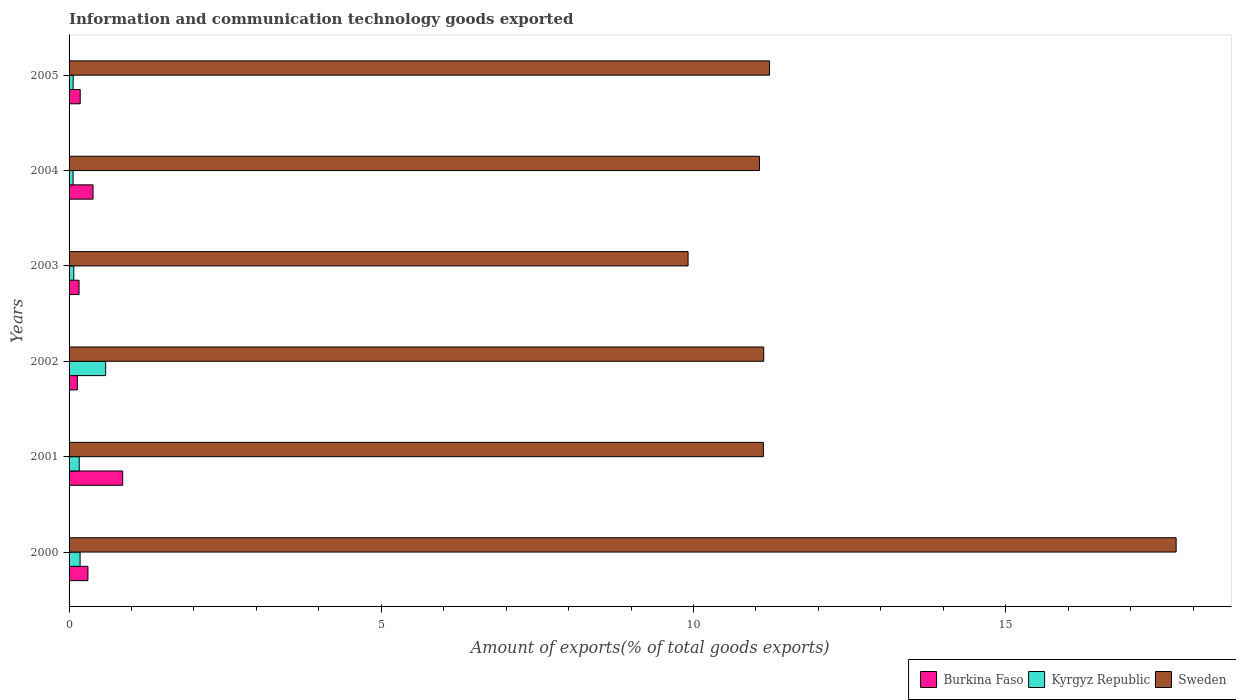How many different coloured bars are there?
Offer a very short reply. 3. How many groups of bars are there?
Offer a very short reply. 6. Are the number of bars on each tick of the Y-axis equal?
Make the answer very short. Yes. How many bars are there on the 4th tick from the top?
Provide a short and direct response. 3. How many bars are there on the 5th tick from the bottom?
Your response must be concise. 3. What is the label of the 5th group of bars from the top?
Provide a short and direct response. 2001. What is the amount of goods exported in Sweden in 2001?
Provide a short and direct response. 11.12. Across all years, what is the maximum amount of goods exported in Burkina Faso?
Your response must be concise. 0.86. Across all years, what is the minimum amount of goods exported in Sweden?
Your response must be concise. 9.91. In which year was the amount of goods exported in Sweden maximum?
Keep it short and to the point. 2000. In which year was the amount of goods exported in Burkina Faso minimum?
Your response must be concise. 2002. What is the total amount of goods exported in Burkina Faso in the graph?
Your answer should be compact. 2.02. What is the difference between the amount of goods exported in Burkina Faso in 2004 and that in 2005?
Offer a terse response. 0.21. What is the difference between the amount of goods exported in Burkina Faso in 2004 and the amount of goods exported in Kyrgyz Republic in 2003?
Provide a succinct answer. 0.31. What is the average amount of goods exported in Sweden per year?
Make the answer very short. 12.03. In the year 2005, what is the difference between the amount of goods exported in Kyrgyz Republic and amount of goods exported in Sweden?
Your answer should be very brief. -11.15. In how many years, is the amount of goods exported in Sweden greater than 1 %?
Ensure brevity in your answer.  6. What is the ratio of the amount of goods exported in Burkina Faso in 2000 to that in 2001?
Your answer should be very brief. 0.35. Is the amount of goods exported in Burkina Faso in 2003 less than that in 2004?
Offer a terse response. Yes. What is the difference between the highest and the second highest amount of goods exported in Burkina Faso?
Your answer should be compact. 0.48. What is the difference between the highest and the lowest amount of goods exported in Kyrgyz Republic?
Your answer should be compact. 0.52. In how many years, is the amount of goods exported in Sweden greater than the average amount of goods exported in Sweden taken over all years?
Offer a very short reply. 1. What does the 1st bar from the top in 2001 represents?
Your answer should be very brief. Sweden. Is it the case that in every year, the sum of the amount of goods exported in Kyrgyz Republic and amount of goods exported in Burkina Faso is greater than the amount of goods exported in Sweden?
Provide a succinct answer. No. Are all the bars in the graph horizontal?
Ensure brevity in your answer.  Yes. How many years are there in the graph?
Offer a terse response. 6. Are the values on the major ticks of X-axis written in scientific E-notation?
Offer a terse response. No. Does the graph contain any zero values?
Your answer should be compact. No. Does the graph contain grids?
Make the answer very short. No. Where does the legend appear in the graph?
Give a very brief answer. Bottom right. How many legend labels are there?
Your answer should be compact. 3. How are the legend labels stacked?
Give a very brief answer. Horizontal. What is the title of the graph?
Provide a short and direct response. Information and communication technology goods exported. What is the label or title of the X-axis?
Provide a short and direct response. Amount of exports(% of total goods exports). What is the Amount of exports(% of total goods exports) in Burkina Faso in 2000?
Provide a succinct answer. 0.3. What is the Amount of exports(% of total goods exports) of Kyrgyz Republic in 2000?
Provide a short and direct response. 0.18. What is the Amount of exports(% of total goods exports) of Sweden in 2000?
Offer a terse response. 17.73. What is the Amount of exports(% of total goods exports) in Burkina Faso in 2001?
Ensure brevity in your answer.  0.86. What is the Amount of exports(% of total goods exports) in Kyrgyz Republic in 2001?
Your response must be concise. 0.16. What is the Amount of exports(% of total goods exports) of Sweden in 2001?
Offer a terse response. 11.12. What is the Amount of exports(% of total goods exports) of Burkina Faso in 2002?
Make the answer very short. 0.13. What is the Amount of exports(% of total goods exports) of Kyrgyz Republic in 2002?
Make the answer very short. 0.59. What is the Amount of exports(% of total goods exports) of Sweden in 2002?
Ensure brevity in your answer.  11.13. What is the Amount of exports(% of total goods exports) of Burkina Faso in 2003?
Make the answer very short. 0.16. What is the Amount of exports(% of total goods exports) in Kyrgyz Republic in 2003?
Give a very brief answer. 0.08. What is the Amount of exports(% of total goods exports) of Sweden in 2003?
Your answer should be compact. 9.91. What is the Amount of exports(% of total goods exports) in Burkina Faso in 2004?
Offer a very short reply. 0.38. What is the Amount of exports(% of total goods exports) in Kyrgyz Republic in 2004?
Your answer should be compact. 0.06. What is the Amount of exports(% of total goods exports) in Sweden in 2004?
Offer a terse response. 11.06. What is the Amount of exports(% of total goods exports) of Burkina Faso in 2005?
Provide a short and direct response. 0.18. What is the Amount of exports(% of total goods exports) of Kyrgyz Republic in 2005?
Offer a very short reply. 0.07. What is the Amount of exports(% of total goods exports) in Sweden in 2005?
Provide a succinct answer. 11.22. Across all years, what is the maximum Amount of exports(% of total goods exports) of Burkina Faso?
Give a very brief answer. 0.86. Across all years, what is the maximum Amount of exports(% of total goods exports) of Kyrgyz Republic?
Offer a very short reply. 0.59. Across all years, what is the maximum Amount of exports(% of total goods exports) in Sweden?
Offer a terse response. 17.73. Across all years, what is the minimum Amount of exports(% of total goods exports) of Burkina Faso?
Provide a short and direct response. 0.13. Across all years, what is the minimum Amount of exports(% of total goods exports) in Kyrgyz Republic?
Your answer should be compact. 0.06. Across all years, what is the minimum Amount of exports(% of total goods exports) of Sweden?
Your answer should be very brief. 9.91. What is the total Amount of exports(% of total goods exports) in Burkina Faso in the graph?
Keep it short and to the point. 2.02. What is the total Amount of exports(% of total goods exports) in Kyrgyz Republic in the graph?
Your response must be concise. 1.13. What is the total Amount of exports(% of total goods exports) in Sweden in the graph?
Keep it short and to the point. 72.16. What is the difference between the Amount of exports(% of total goods exports) of Burkina Faso in 2000 and that in 2001?
Provide a short and direct response. -0.56. What is the difference between the Amount of exports(% of total goods exports) of Kyrgyz Republic in 2000 and that in 2001?
Offer a terse response. 0.01. What is the difference between the Amount of exports(% of total goods exports) of Sweden in 2000 and that in 2001?
Make the answer very short. 6.61. What is the difference between the Amount of exports(% of total goods exports) in Burkina Faso in 2000 and that in 2002?
Give a very brief answer. 0.17. What is the difference between the Amount of exports(% of total goods exports) in Kyrgyz Republic in 2000 and that in 2002?
Offer a terse response. -0.41. What is the difference between the Amount of exports(% of total goods exports) of Sweden in 2000 and that in 2002?
Your answer should be very brief. 6.6. What is the difference between the Amount of exports(% of total goods exports) in Burkina Faso in 2000 and that in 2003?
Your answer should be compact. 0.14. What is the difference between the Amount of exports(% of total goods exports) in Kyrgyz Republic in 2000 and that in 2003?
Your answer should be very brief. 0.1. What is the difference between the Amount of exports(% of total goods exports) of Sweden in 2000 and that in 2003?
Provide a succinct answer. 7.82. What is the difference between the Amount of exports(% of total goods exports) of Burkina Faso in 2000 and that in 2004?
Give a very brief answer. -0.08. What is the difference between the Amount of exports(% of total goods exports) in Kyrgyz Republic in 2000 and that in 2004?
Ensure brevity in your answer.  0.11. What is the difference between the Amount of exports(% of total goods exports) in Sweden in 2000 and that in 2004?
Your response must be concise. 6.67. What is the difference between the Amount of exports(% of total goods exports) of Burkina Faso in 2000 and that in 2005?
Keep it short and to the point. 0.12. What is the difference between the Amount of exports(% of total goods exports) of Kyrgyz Republic in 2000 and that in 2005?
Your answer should be very brief. 0.11. What is the difference between the Amount of exports(% of total goods exports) of Sweden in 2000 and that in 2005?
Offer a very short reply. 6.51. What is the difference between the Amount of exports(% of total goods exports) in Burkina Faso in 2001 and that in 2002?
Ensure brevity in your answer.  0.73. What is the difference between the Amount of exports(% of total goods exports) of Kyrgyz Republic in 2001 and that in 2002?
Ensure brevity in your answer.  -0.42. What is the difference between the Amount of exports(% of total goods exports) in Sweden in 2001 and that in 2002?
Offer a terse response. -0.01. What is the difference between the Amount of exports(% of total goods exports) of Burkina Faso in 2001 and that in 2003?
Ensure brevity in your answer.  0.7. What is the difference between the Amount of exports(% of total goods exports) in Kyrgyz Republic in 2001 and that in 2003?
Provide a short and direct response. 0.09. What is the difference between the Amount of exports(% of total goods exports) in Sweden in 2001 and that in 2003?
Give a very brief answer. 1.21. What is the difference between the Amount of exports(% of total goods exports) in Burkina Faso in 2001 and that in 2004?
Your answer should be compact. 0.47. What is the difference between the Amount of exports(% of total goods exports) in Kyrgyz Republic in 2001 and that in 2004?
Provide a succinct answer. 0.1. What is the difference between the Amount of exports(% of total goods exports) in Sweden in 2001 and that in 2004?
Provide a short and direct response. 0.06. What is the difference between the Amount of exports(% of total goods exports) of Burkina Faso in 2001 and that in 2005?
Offer a terse response. 0.68. What is the difference between the Amount of exports(% of total goods exports) in Kyrgyz Republic in 2001 and that in 2005?
Your answer should be compact. 0.1. What is the difference between the Amount of exports(% of total goods exports) of Sweden in 2001 and that in 2005?
Provide a succinct answer. -0.1. What is the difference between the Amount of exports(% of total goods exports) of Burkina Faso in 2002 and that in 2003?
Offer a terse response. -0.03. What is the difference between the Amount of exports(% of total goods exports) in Kyrgyz Republic in 2002 and that in 2003?
Your response must be concise. 0.51. What is the difference between the Amount of exports(% of total goods exports) in Sweden in 2002 and that in 2003?
Your answer should be very brief. 1.21. What is the difference between the Amount of exports(% of total goods exports) of Burkina Faso in 2002 and that in 2004?
Your answer should be very brief. -0.25. What is the difference between the Amount of exports(% of total goods exports) in Kyrgyz Republic in 2002 and that in 2004?
Your answer should be compact. 0.52. What is the difference between the Amount of exports(% of total goods exports) in Sweden in 2002 and that in 2004?
Keep it short and to the point. 0.07. What is the difference between the Amount of exports(% of total goods exports) of Burkina Faso in 2002 and that in 2005?
Your answer should be very brief. -0.05. What is the difference between the Amount of exports(% of total goods exports) of Kyrgyz Republic in 2002 and that in 2005?
Your response must be concise. 0.52. What is the difference between the Amount of exports(% of total goods exports) in Sweden in 2002 and that in 2005?
Your response must be concise. -0.09. What is the difference between the Amount of exports(% of total goods exports) of Burkina Faso in 2003 and that in 2004?
Make the answer very short. -0.22. What is the difference between the Amount of exports(% of total goods exports) of Kyrgyz Republic in 2003 and that in 2004?
Provide a short and direct response. 0.01. What is the difference between the Amount of exports(% of total goods exports) in Sweden in 2003 and that in 2004?
Give a very brief answer. -1.14. What is the difference between the Amount of exports(% of total goods exports) in Burkina Faso in 2003 and that in 2005?
Your answer should be compact. -0.02. What is the difference between the Amount of exports(% of total goods exports) in Kyrgyz Republic in 2003 and that in 2005?
Your answer should be very brief. 0.01. What is the difference between the Amount of exports(% of total goods exports) in Sweden in 2003 and that in 2005?
Offer a terse response. -1.3. What is the difference between the Amount of exports(% of total goods exports) in Burkina Faso in 2004 and that in 2005?
Your response must be concise. 0.21. What is the difference between the Amount of exports(% of total goods exports) in Kyrgyz Republic in 2004 and that in 2005?
Your answer should be compact. -0. What is the difference between the Amount of exports(% of total goods exports) of Sweden in 2004 and that in 2005?
Ensure brevity in your answer.  -0.16. What is the difference between the Amount of exports(% of total goods exports) of Burkina Faso in 2000 and the Amount of exports(% of total goods exports) of Kyrgyz Republic in 2001?
Keep it short and to the point. 0.14. What is the difference between the Amount of exports(% of total goods exports) of Burkina Faso in 2000 and the Amount of exports(% of total goods exports) of Sweden in 2001?
Provide a short and direct response. -10.82. What is the difference between the Amount of exports(% of total goods exports) of Kyrgyz Republic in 2000 and the Amount of exports(% of total goods exports) of Sweden in 2001?
Ensure brevity in your answer.  -10.94. What is the difference between the Amount of exports(% of total goods exports) of Burkina Faso in 2000 and the Amount of exports(% of total goods exports) of Kyrgyz Republic in 2002?
Provide a short and direct response. -0.28. What is the difference between the Amount of exports(% of total goods exports) of Burkina Faso in 2000 and the Amount of exports(% of total goods exports) of Sweden in 2002?
Keep it short and to the point. -10.82. What is the difference between the Amount of exports(% of total goods exports) in Kyrgyz Republic in 2000 and the Amount of exports(% of total goods exports) in Sweden in 2002?
Make the answer very short. -10.95. What is the difference between the Amount of exports(% of total goods exports) in Burkina Faso in 2000 and the Amount of exports(% of total goods exports) in Kyrgyz Republic in 2003?
Offer a terse response. 0.23. What is the difference between the Amount of exports(% of total goods exports) in Burkina Faso in 2000 and the Amount of exports(% of total goods exports) in Sweden in 2003?
Give a very brief answer. -9.61. What is the difference between the Amount of exports(% of total goods exports) of Kyrgyz Republic in 2000 and the Amount of exports(% of total goods exports) of Sweden in 2003?
Your response must be concise. -9.74. What is the difference between the Amount of exports(% of total goods exports) in Burkina Faso in 2000 and the Amount of exports(% of total goods exports) in Kyrgyz Republic in 2004?
Your answer should be compact. 0.24. What is the difference between the Amount of exports(% of total goods exports) of Burkina Faso in 2000 and the Amount of exports(% of total goods exports) of Sweden in 2004?
Provide a short and direct response. -10.75. What is the difference between the Amount of exports(% of total goods exports) of Kyrgyz Republic in 2000 and the Amount of exports(% of total goods exports) of Sweden in 2004?
Ensure brevity in your answer.  -10.88. What is the difference between the Amount of exports(% of total goods exports) of Burkina Faso in 2000 and the Amount of exports(% of total goods exports) of Kyrgyz Republic in 2005?
Provide a short and direct response. 0.24. What is the difference between the Amount of exports(% of total goods exports) of Burkina Faso in 2000 and the Amount of exports(% of total goods exports) of Sweden in 2005?
Offer a terse response. -10.92. What is the difference between the Amount of exports(% of total goods exports) of Kyrgyz Republic in 2000 and the Amount of exports(% of total goods exports) of Sweden in 2005?
Provide a succinct answer. -11.04. What is the difference between the Amount of exports(% of total goods exports) of Burkina Faso in 2001 and the Amount of exports(% of total goods exports) of Kyrgyz Republic in 2002?
Your answer should be very brief. 0.27. What is the difference between the Amount of exports(% of total goods exports) in Burkina Faso in 2001 and the Amount of exports(% of total goods exports) in Sweden in 2002?
Offer a very short reply. -10.27. What is the difference between the Amount of exports(% of total goods exports) of Kyrgyz Republic in 2001 and the Amount of exports(% of total goods exports) of Sweden in 2002?
Provide a succinct answer. -10.96. What is the difference between the Amount of exports(% of total goods exports) of Burkina Faso in 2001 and the Amount of exports(% of total goods exports) of Kyrgyz Republic in 2003?
Your response must be concise. 0.78. What is the difference between the Amount of exports(% of total goods exports) in Burkina Faso in 2001 and the Amount of exports(% of total goods exports) in Sweden in 2003?
Keep it short and to the point. -9.05. What is the difference between the Amount of exports(% of total goods exports) in Kyrgyz Republic in 2001 and the Amount of exports(% of total goods exports) in Sweden in 2003?
Keep it short and to the point. -9.75. What is the difference between the Amount of exports(% of total goods exports) of Burkina Faso in 2001 and the Amount of exports(% of total goods exports) of Kyrgyz Republic in 2004?
Provide a short and direct response. 0.8. What is the difference between the Amount of exports(% of total goods exports) in Burkina Faso in 2001 and the Amount of exports(% of total goods exports) in Sweden in 2004?
Provide a short and direct response. -10.2. What is the difference between the Amount of exports(% of total goods exports) in Kyrgyz Republic in 2001 and the Amount of exports(% of total goods exports) in Sweden in 2004?
Provide a succinct answer. -10.89. What is the difference between the Amount of exports(% of total goods exports) of Burkina Faso in 2001 and the Amount of exports(% of total goods exports) of Kyrgyz Republic in 2005?
Your answer should be compact. 0.79. What is the difference between the Amount of exports(% of total goods exports) in Burkina Faso in 2001 and the Amount of exports(% of total goods exports) in Sweden in 2005?
Offer a terse response. -10.36. What is the difference between the Amount of exports(% of total goods exports) of Kyrgyz Republic in 2001 and the Amount of exports(% of total goods exports) of Sweden in 2005?
Your response must be concise. -11.06. What is the difference between the Amount of exports(% of total goods exports) in Burkina Faso in 2002 and the Amount of exports(% of total goods exports) in Kyrgyz Republic in 2003?
Provide a succinct answer. 0.06. What is the difference between the Amount of exports(% of total goods exports) in Burkina Faso in 2002 and the Amount of exports(% of total goods exports) in Sweden in 2003?
Ensure brevity in your answer.  -9.78. What is the difference between the Amount of exports(% of total goods exports) in Kyrgyz Republic in 2002 and the Amount of exports(% of total goods exports) in Sweden in 2003?
Give a very brief answer. -9.33. What is the difference between the Amount of exports(% of total goods exports) in Burkina Faso in 2002 and the Amount of exports(% of total goods exports) in Kyrgyz Republic in 2004?
Make the answer very short. 0.07. What is the difference between the Amount of exports(% of total goods exports) in Burkina Faso in 2002 and the Amount of exports(% of total goods exports) in Sweden in 2004?
Provide a succinct answer. -10.92. What is the difference between the Amount of exports(% of total goods exports) of Kyrgyz Republic in 2002 and the Amount of exports(% of total goods exports) of Sweden in 2004?
Offer a terse response. -10.47. What is the difference between the Amount of exports(% of total goods exports) in Burkina Faso in 2002 and the Amount of exports(% of total goods exports) in Kyrgyz Republic in 2005?
Make the answer very short. 0.07. What is the difference between the Amount of exports(% of total goods exports) in Burkina Faso in 2002 and the Amount of exports(% of total goods exports) in Sweden in 2005?
Provide a short and direct response. -11.09. What is the difference between the Amount of exports(% of total goods exports) of Kyrgyz Republic in 2002 and the Amount of exports(% of total goods exports) of Sweden in 2005?
Provide a short and direct response. -10.63. What is the difference between the Amount of exports(% of total goods exports) in Burkina Faso in 2003 and the Amount of exports(% of total goods exports) in Kyrgyz Republic in 2004?
Provide a succinct answer. 0.1. What is the difference between the Amount of exports(% of total goods exports) of Burkina Faso in 2003 and the Amount of exports(% of total goods exports) of Sweden in 2004?
Your response must be concise. -10.9. What is the difference between the Amount of exports(% of total goods exports) of Kyrgyz Republic in 2003 and the Amount of exports(% of total goods exports) of Sweden in 2004?
Your response must be concise. -10.98. What is the difference between the Amount of exports(% of total goods exports) of Burkina Faso in 2003 and the Amount of exports(% of total goods exports) of Kyrgyz Republic in 2005?
Your answer should be compact. 0.09. What is the difference between the Amount of exports(% of total goods exports) of Burkina Faso in 2003 and the Amount of exports(% of total goods exports) of Sweden in 2005?
Keep it short and to the point. -11.06. What is the difference between the Amount of exports(% of total goods exports) of Kyrgyz Republic in 2003 and the Amount of exports(% of total goods exports) of Sweden in 2005?
Your answer should be compact. -11.14. What is the difference between the Amount of exports(% of total goods exports) of Burkina Faso in 2004 and the Amount of exports(% of total goods exports) of Kyrgyz Republic in 2005?
Make the answer very short. 0.32. What is the difference between the Amount of exports(% of total goods exports) of Burkina Faso in 2004 and the Amount of exports(% of total goods exports) of Sweden in 2005?
Give a very brief answer. -10.83. What is the difference between the Amount of exports(% of total goods exports) of Kyrgyz Republic in 2004 and the Amount of exports(% of total goods exports) of Sweden in 2005?
Provide a succinct answer. -11.15. What is the average Amount of exports(% of total goods exports) in Burkina Faso per year?
Your answer should be very brief. 0.34. What is the average Amount of exports(% of total goods exports) in Kyrgyz Republic per year?
Keep it short and to the point. 0.19. What is the average Amount of exports(% of total goods exports) of Sweden per year?
Your answer should be very brief. 12.03. In the year 2000, what is the difference between the Amount of exports(% of total goods exports) of Burkina Faso and Amount of exports(% of total goods exports) of Kyrgyz Republic?
Your answer should be compact. 0.13. In the year 2000, what is the difference between the Amount of exports(% of total goods exports) of Burkina Faso and Amount of exports(% of total goods exports) of Sweden?
Make the answer very short. -17.43. In the year 2000, what is the difference between the Amount of exports(% of total goods exports) of Kyrgyz Republic and Amount of exports(% of total goods exports) of Sweden?
Ensure brevity in your answer.  -17.55. In the year 2001, what is the difference between the Amount of exports(% of total goods exports) in Burkina Faso and Amount of exports(% of total goods exports) in Kyrgyz Republic?
Keep it short and to the point. 0.7. In the year 2001, what is the difference between the Amount of exports(% of total goods exports) in Burkina Faso and Amount of exports(% of total goods exports) in Sweden?
Keep it short and to the point. -10.26. In the year 2001, what is the difference between the Amount of exports(% of total goods exports) in Kyrgyz Republic and Amount of exports(% of total goods exports) in Sweden?
Your answer should be compact. -10.96. In the year 2002, what is the difference between the Amount of exports(% of total goods exports) of Burkina Faso and Amount of exports(% of total goods exports) of Kyrgyz Republic?
Your response must be concise. -0.45. In the year 2002, what is the difference between the Amount of exports(% of total goods exports) of Burkina Faso and Amount of exports(% of total goods exports) of Sweden?
Make the answer very short. -10.99. In the year 2002, what is the difference between the Amount of exports(% of total goods exports) of Kyrgyz Republic and Amount of exports(% of total goods exports) of Sweden?
Offer a very short reply. -10.54. In the year 2003, what is the difference between the Amount of exports(% of total goods exports) in Burkina Faso and Amount of exports(% of total goods exports) in Kyrgyz Republic?
Offer a very short reply. 0.08. In the year 2003, what is the difference between the Amount of exports(% of total goods exports) of Burkina Faso and Amount of exports(% of total goods exports) of Sweden?
Keep it short and to the point. -9.75. In the year 2003, what is the difference between the Amount of exports(% of total goods exports) of Kyrgyz Republic and Amount of exports(% of total goods exports) of Sweden?
Your response must be concise. -9.84. In the year 2004, what is the difference between the Amount of exports(% of total goods exports) of Burkina Faso and Amount of exports(% of total goods exports) of Kyrgyz Republic?
Your answer should be compact. 0.32. In the year 2004, what is the difference between the Amount of exports(% of total goods exports) in Burkina Faso and Amount of exports(% of total goods exports) in Sweden?
Ensure brevity in your answer.  -10.67. In the year 2004, what is the difference between the Amount of exports(% of total goods exports) in Kyrgyz Republic and Amount of exports(% of total goods exports) in Sweden?
Offer a terse response. -10.99. In the year 2005, what is the difference between the Amount of exports(% of total goods exports) of Burkina Faso and Amount of exports(% of total goods exports) of Kyrgyz Republic?
Keep it short and to the point. 0.11. In the year 2005, what is the difference between the Amount of exports(% of total goods exports) of Burkina Faso and Amount of exports(% of total goods exports) of Sweden?
Your answer should be very brief. -11.04. In the year 2005, what is the difference between the Amount of exports(% of total goods exports) in Kyrgyz Republic and Amount of exports(% of total goods exports) in Sweden?
Make the answer very short. -11.15. What is the ratio of the Amount of exports(% of total goods exports) in Burkina Faso in 2000 to that in 2001?
Your response must be concise. 0.35. What is the ratio of the Amount of exports(% of total goods exports) in Kyrgyz Republic in 2000 to that in 2001?
Give a very brief answer. 1.09. What is the ratio of the Amount of exports(% of total goods exports) of Sweden in 2000 to that in 2001?
Ensure brevity in your answer.  1.59. What is the ratio of the Amount of exports(% of total goods exports) of Burkina Faso in 2000 to that in 2002?
Your answer should be compact. 2.28. What is the ratio of the Amount of exports(% of total goods exports) of Kyrgyz Republic in 2000 to that in 2002?
Ensure brevity in your answer.  0.3. What is the ratio of the Amount of exports(% of total goods exports) of Sweden in 2000 to that in 2002?
Your answer should be very brief. 1.59. What is the ratio of the Amount of exports(% of total goods exports) in Burkina Faso in 2000 to that in 2003?
Ensure brevity in your answer.  1.89. What is the ratio of the Amount of exports(% of total goods exports) in Kyrgyz Republic in 2000 to that in 2003?
Ensure brevity in your answer.  2.33. What is the ratio of the Amount of exports(% of total goods exports) of Sweden in 2000 to that in 2003?
Offer a very short reply. 1.79. What is the ratio of the Amount of exports(% of total goods exports) of Burkina Faso in 2000 to that in 2004?
Your response must be concise. 0.79. What is the ratio of the Amount of exports(% of total goods exports) in Kyrgyz Republic in 2000 to that in 2004?
Your answer should be compact. 2.76. What is the ratio of the Amount of exports(% of total goods exports) in Sweden in 2000 to that in 2004?
Give a very brief answer. 1.6. What is the ratio of the Amount of exports(% of total goods exports) of Burkina Faso in 2000 to that in 2005?
Offer a very short reply. 1.69. What is the ratio of the Amount of exports(% of total goods exports) in Kyrgyz Republic in 2000 to that in 2005?
Your answer should be compact. 2.71. What is the ratio of the Amount of exports(% of total goods exports) in Sweden in 2000 to that in 2005?
Your answer should be compact. 1.58. What is the ratio of the Amount of exports(% of total goods exports) in Burkina Faso in 2001 to that in 2002?
Offer a very short reply. 6.48. What is the ratio of the Amount of exports(% of total goods exports) in Kyrgyz Republic in 2001 to that in 2002?
Your response must be concise. 0.28. What is the ratio of the Amount of exports(% of total goods exports) in Burkina Faso in 2001 to that in 2003?
Offer a terse response. 5.37. What is the ratio of the Amount of exports(% of total goods exports) of Kyrgyz Republic in 2001 to that in 2003?
Offer a very short reply. 2.15. What is the ratio of the Amount of exports(% of total goods exports) in Sweden in 2001 to that in 2003?
Provide a short and direct response. 1.12. What is the ratio of the Amount of exports(% of total goods exports) in Burkina Faso in 2001 to that in 2004?
Make the answer very short. 2.24. What is the ratio of the Amount of exports(% of total goods exports) of Kyrgyz Republic in 2001 to that in 2004?
Ensure brevity in your answer.  2.54. What is the ratio of the Amount of exports(% of total goods exports) of Burkina Faso in 2001 to that in 2005?
Provide a succinct answer. 4.81. What is the ratio of the Amount of exports(% of total goods exports) of Kyrgyz Republic in 2001 to that in 2005?
Ensure brevity in your answer.  2.49. What is the ratio of the Amount of exports(% of total goods exports) of Sweden in 2001 to that in 2005?
Offer a terse response. 0.99. What is the ratio of the Amount of exports(% of total goods exports) in Burkina Faso in 2002 to that in 2003?
Your answer should be compact. 0.83. What is the ratio of the Amount of exports(% of total goods exports) of Kyrgyz Republic in 2002 to that in 2003?
Provide a succinct answer. 7.74. What is the ratio of the Amount of exports(% of total goods exports) of Sweden in 2002 to that in 2003?
Your answer should be very brief. 1.12. What is the ratio of the Amount of exports(% of total goods exports) of Burkina Faso in 2002 to that in 2004?
Your response must be concise. 0.34. What is the ratio of the Amount of exports(% of total goods exports) in Kyrgyz Republic in 2002 to that in 2004?
Provide a short and direct response. 9.15. What is the ratio of the Amount of exports(% of total goods exports) of Sweden in 2002 to that in 2004?
Offer a terse response. 1.01. What is the ratio of the Amount of exports(% of total goods exports) of Burkina Faso in 2002 to that in 2005?
Your answer should be compact. 0.74. What is the ratio of the Amount of exports(% of total goods exports) of Kyrgyz Republic in 2002 to that in 2005?
Make the answer very short. 8.99. What is the ratio of the Amount of exports(% of total goods exports) of Burkina Faso in 2003 to that in 2004?
Make the answer very short. 0.42. What is the ratio of the Amount of exports(% of total goods exports) of Kyrgyz Republic in 2003 to that in 2004?
Your response must be concise. 1.18. What is the ratio of the Amount of exports(% of total goods exports) of Sweden in 2003 to that in 2004?
Your answer should be compact. 0.9. What is the ratio of the Amount of exports(% of total goods exports) of Burkina Faso in 2003 to that in 2005?
Offer a terse response. 0.9. What is the ratio of the Amount of exports(% of total goods exports) in Kyrgyz Republic in 2003 to that in 2005?
Your answer should be very brief. 1.16. What is the ratio of the Amount of exports(% of total goods exports) of Sweden in 2003 to that in 2005?
Your answer should be very brief. 0.88. What is the ratio of the Amount of exports(% of total goods exports) in Burkina Faso in 2004 to that in 2005?
Your response must be concise. 2.15. What is the ratio of the Amount of exports(% of total goods exports) of Kyrgyz Republic in 2004 to that in 2005?
Your answer should be compact. 0.98. What is the ratio of the Amount of exports(% of total goods exports) in Sweden in 2004 to that in 2005?
Make the answer very short. 0.99. What is the difference between the highest and the second highest Amount of exports(% of total goods exports) of Burkina Faso?
Offer a terse response. 0.47. What is the difference between the highest and the second highest Amount of exports(% of total goods exports) of Kyrgyz Republic?
Give a very brief answer. 0.41. What is the difference between the highest and the second highest Amount of exports(% of total goods exports) of Sweden?
Keep it short and to the point. 6.51. What is the difference between the highest and the lowest Amount of exports(% of total goods exports) in Burkina Faso?
Your answer should be compact. 0.73. What is the difference between the highest and the lowest Amount of exports(% of total goods exports) of Kyrgyz Republic?
Make the answer very short. 0.52. What is the difference between the highest and the lowest Amount of exports(% of total goods exports) in Sweden?
Ensure brevity in your answer.  7.82. 